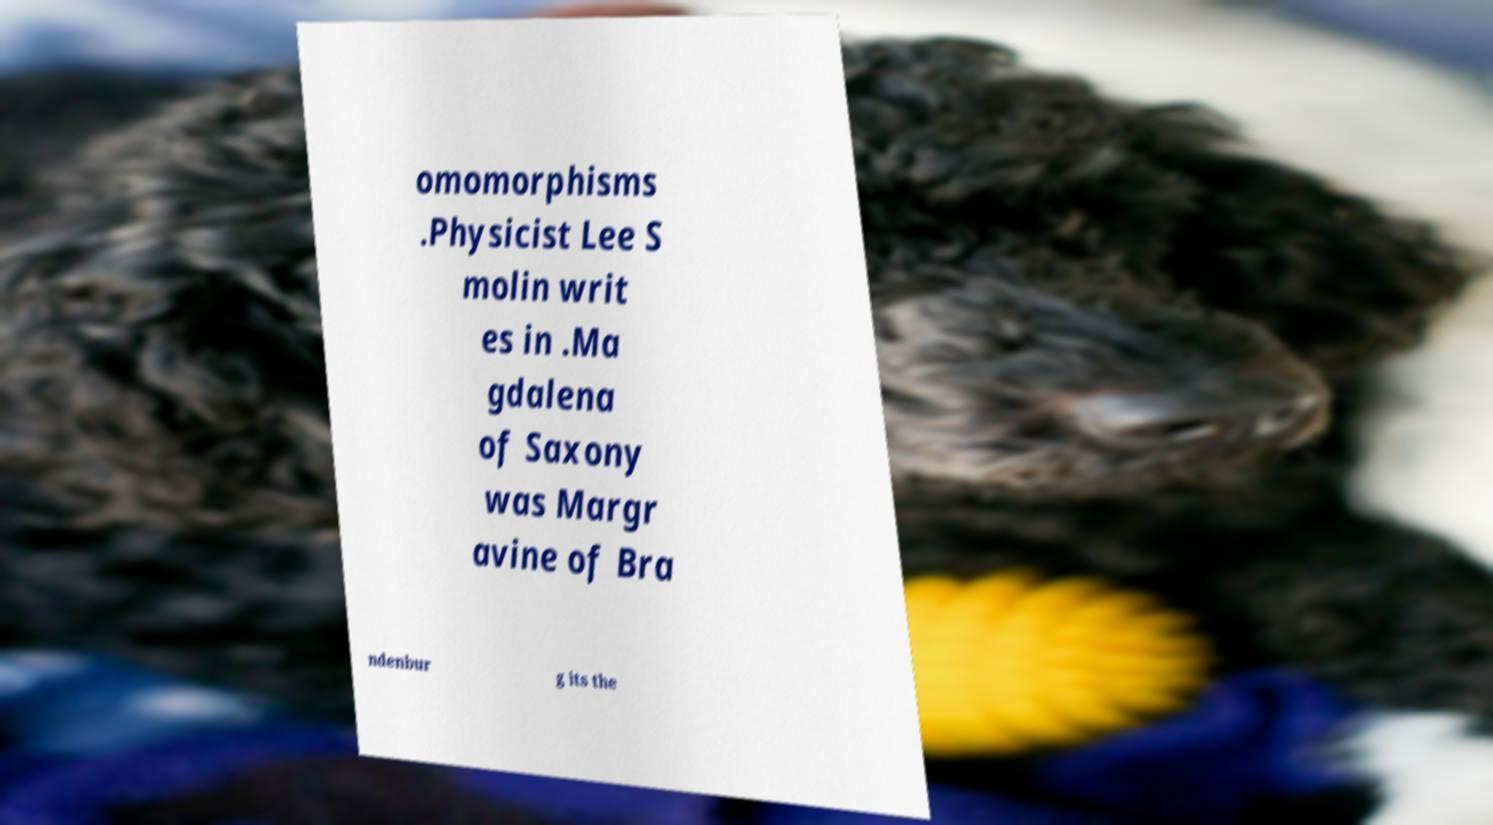There's text embedded in this image that I need extracted. Can you transcribe it verbatim? omomorphisms .Physicist Lee S molin writ es in .Ma gdalena of Saxony was Margr avine of Bra ndenbur g its the 